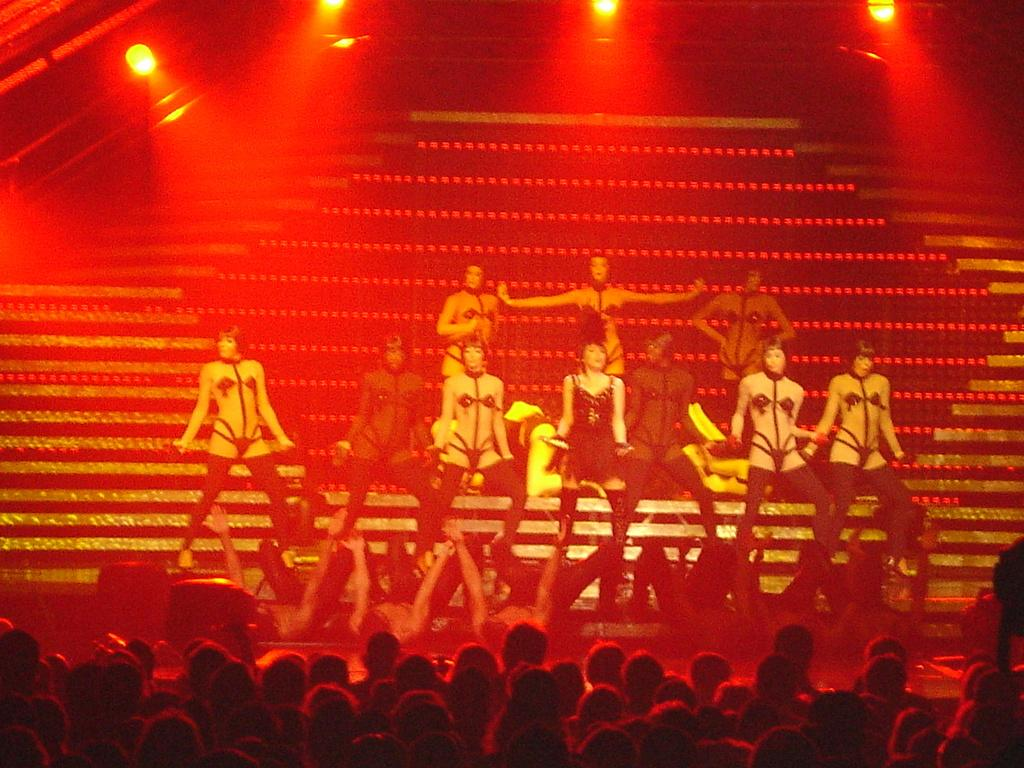What are the people in the image doing? The people in the image are dancing. Are there any spectators in the image? Yes, there is an audience in the image. What can be seen in the background of the image? There are steps and lights in the background of the image. What type of lumber is being used to build the coast in the image? There is no coast or lumber present in the image. How does the audience express their shame during the performance in the image? There is no indication of shame or any negative emotions in the image; the people are simply dancing and the audience is watching. 